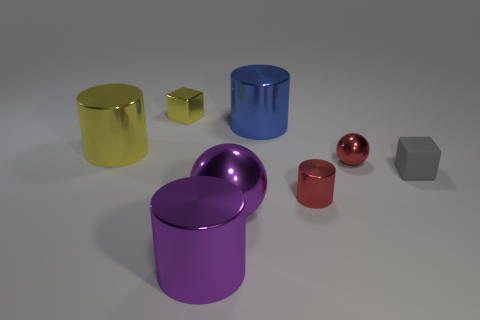Add 2 big purple metallic cylinders. How many objects exist? 10 Subtract all cubes. How many objects are left? 6 Add 7 rubber cubes. How many rubber cubes are left? 8 Add 7 big purple metal cylinders. How many big purple metal cylinders exist? 8 Subtract 1 gray blocks. How many objects are left? 7 Subtract all large yellow matte blocks. Subtract all red objects. How many objects are left? 6 